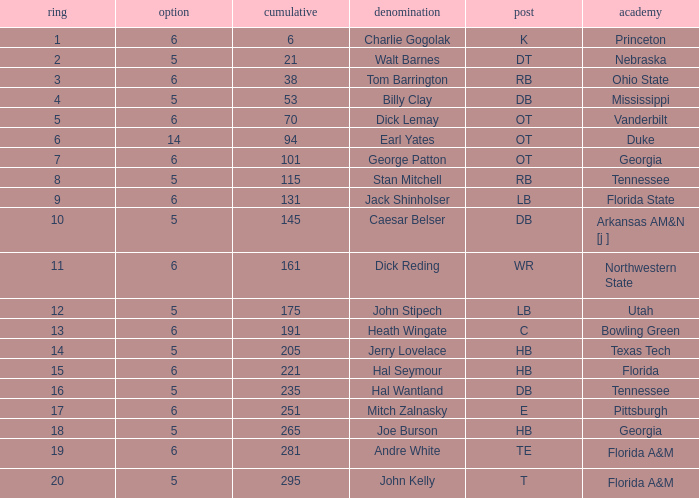What is Pick, when Round is 15? 6.0. 